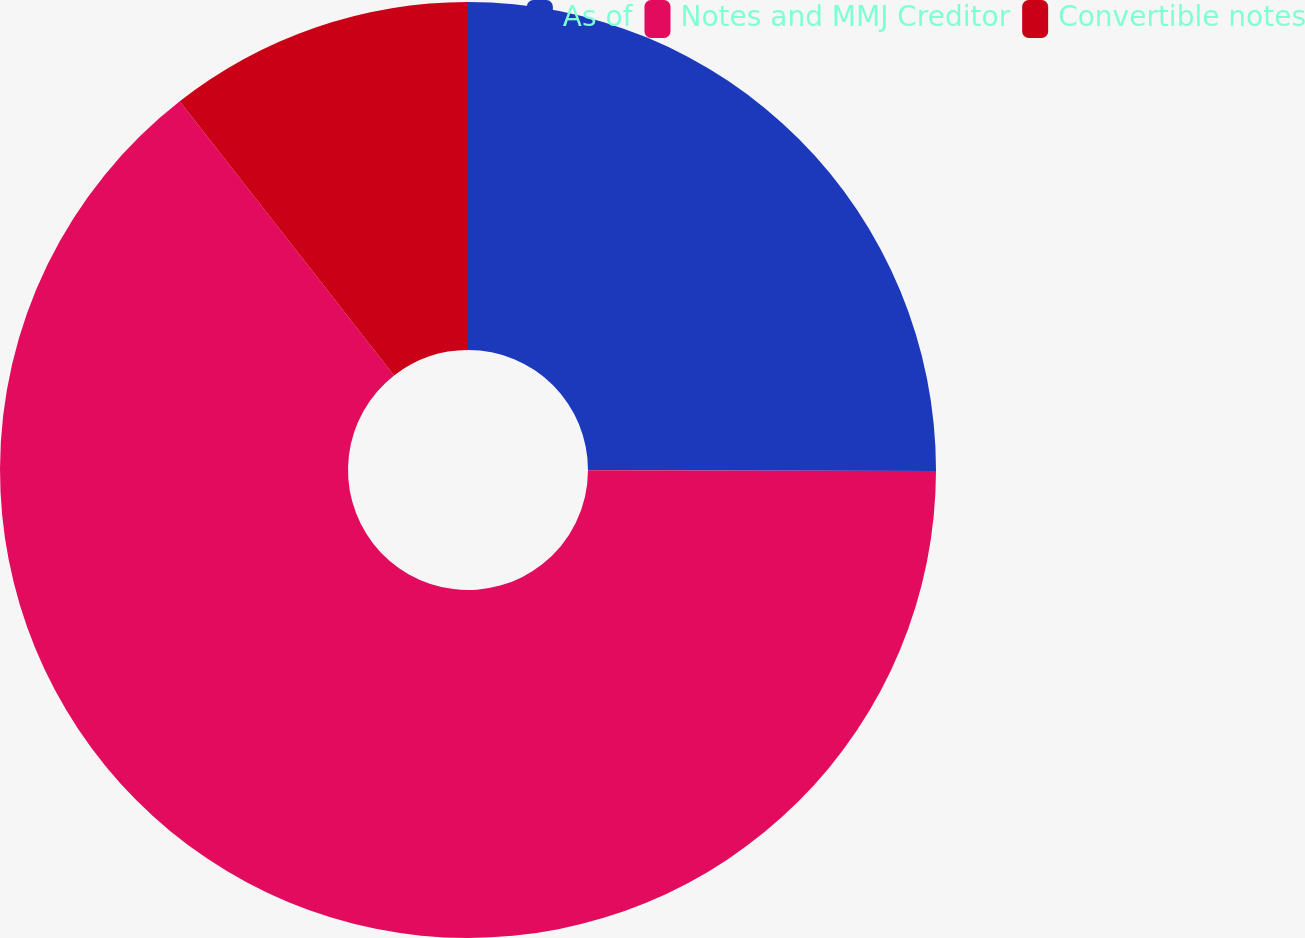Convert chart. <chart><loc_0><loc_0><loc_500><loc_500><pie_chart><fcel>As of<fcel>Notes and MMJ Creditor<fcel>Convertible notes<nl><fcel>25.03%<fcel>64.4%<fcel>10.56%<nl></chart> 